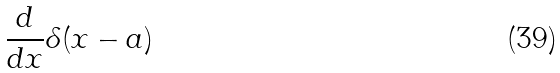Convert formula to latex. <formula><loc_0><loc_0><loc_500><loc_500>\frac { d } { d x } \delta ( x - a )</formula> 